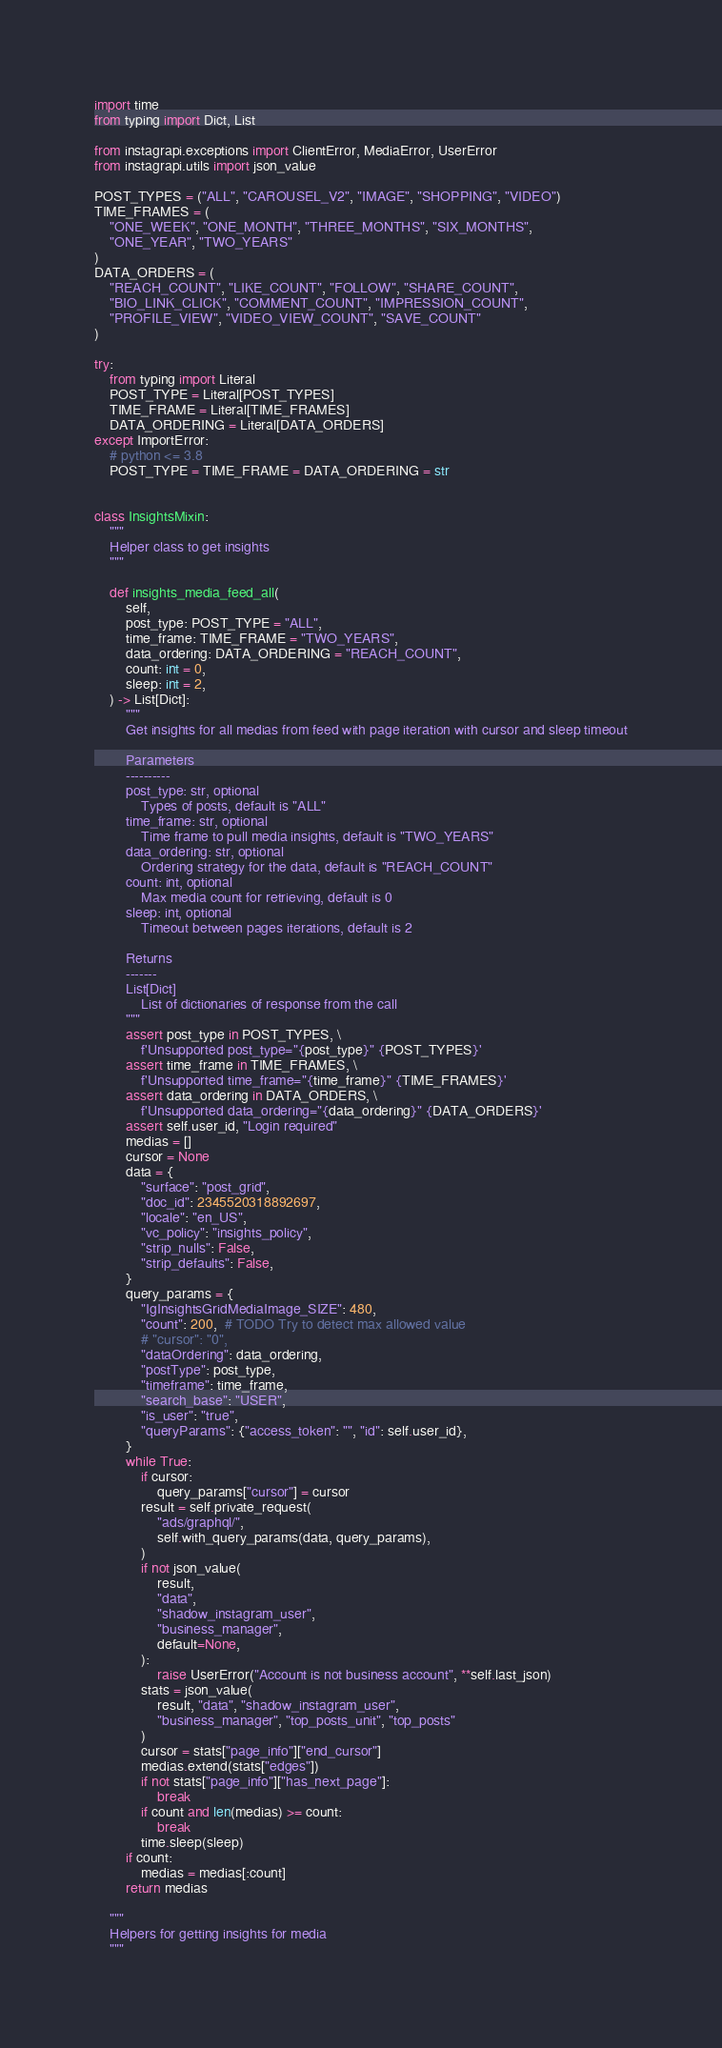<code> <loc_0><loc_0><loc_500><loc_500><_Python_>import time
from typing import Dict, List

from instagrapi.exceptions import ClientError, MediaError, UserError
from instagrapi.utils import json_value

POST_TYPES = ("ALL", "CAROUSEL_V2", "IMAGE", "SHOPPING", "VIDEO")
TIME_FRAMES = (
    "ONE_WEEK", "ONE_MONTH", "THREE_MONTHS", "SIX_MONTHS",
    "ONE_YEAR", "TWO_YEARS"
)
DATA_ORDERS = (
    "REACH_COUNT", "LIKE_COUNT", "FOLLOW", "SHARE_COUNT",
    "BIO_LINK_CLICK", "COMMENT_COUNT", "IMPRESSION_COUNT",
    "PROFILE_VIEW", "VIDEO_VIEW_COUNT", "SAVE_COUNT"
)

try:
    from typing import Literal
    POST_TYPE = Literal[POST_TYPES]
    TIME_FRAME = Literal[TIME_FRAMES]
    DATA_ORDERING = Literal[DATA_ORDERS]
except ImportError:
    # python <= 3.8
    POST_TYPE = TIME_FRAME = DATA_ORDERING = str


class InsightsMixin:
    """
    Helper class to get insights
    """

    def insights_media_feed_all(
        self,
        post_type: POST_TYPE = "ALL",
        time_frame: TIME_FRAME = "TWO_YEARS",
        data_ordering: DATA_ORDERING = "REACH_COUNT",
        count: int = 0,
        sleep: int = 2,
    ) -> List[Dict]:
        """
        Get insights for all medias from feed with page iteration with cursor and sleep timeout

        Parameters
        ----------
        post_type: str, optional
            Types of posts, default is "ALL"
        time_frame: str, optional
            Time frame to pull media insights, default is "TWO_YEARS"
        data_ordering: str, optional
            Ordering strategy for the data, default is "REACH_COUNT"
        count: int, optional
            Max media count for retrieving, default is 0
        sleep: int, optional
            Timeout between pages iterations, default is 2

        Returns
        -------
        List[Dict]
            List of dictionaries of response from the call
        """
        assert post_type in POST_TYPES, \
            f'Unsupported post_type="{post_type}" {POST_TYPES}'
        assert time_frame in TIME_FRAMES, \
            f'Unsupported time_frame="{time_frame}" {TIME_FRAMES}'
        assert data_ordering in DATA_ORDERS, \
            f'Unsupported data_ordering="{data_ordering}" {DATA_ORDERS}'
        assert self.user_id, "Login required"
        medias = []
        cursor = None
        data = {
            "surface": "post_grid",
            "doc_id": 2345520318892697,
            "locale": "en_US",
            "vc_policy": "insights_policy",
            "strip_nulls": False,
            "strip_defaults": False,
        }
        query_params = {
            "IgInsightsGridMediaImage_SIZE": 480,
            "count": 200,  # TODO Try to detect max allowed value
            # "cursor": "0",
            "dataOrdering": data_ordering,
            "postType": post_type,
            "timeframe": time_frame,
            "search_base": "USER",
            "is_user": "true",
            "queryParams": {"access_token": "", "id": self.user_id},
        }
        while True:
            if cursor:
                query_params["cursor"] = cursor
            result = self.private_request(
                "ads/graphql/",
                self.with_query_params(data, query_params),
            )
            if not json_value(
                result,
                "data",
                "shadow_instagram_user",
                "business_manager",
                default=None,
            ):
                raise UserError("Account is not business account", **self.last_json)
            stats = json_value(
                result, "data", "shadow_instagram_user",
                "business_manager", "top_posts_unit", "top_posts"
            )
            cursor = stats["page_info"]["end_cursor"]
            medias.extend(stats["edges"])
            if not stats["page_info"]["has_next_page"]:
                break
            if count and len(medias) >= count:
                break
            time.sleep(sleep)
        if count:
            medias = medias[:count]
        return medias

    """
    Helpers for getting insights for media
    """
</code> 